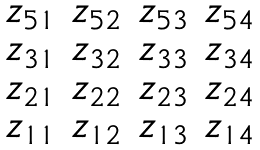<formula> <loc_0><loc_0><loc_500><loc_500>\begin{matrix} z _ { 5 1 } & z _ { 5 2 } & z _ { 5 3 } & z _ { 5 4 } \\ z _ { 3 1 } & z _ { 3 2 } & z _ { 3 3 } & z _ { 3 4 } \\ z _ { 2 1 } & z _ { 2 2 } & z _ { 2 3 } & z _ { 2 4 } \\ z _ { 1 1 } & z _ { 1 2 } & z _ { 1 3 } & z _ { 1 4 } \\ \end{matrix}</formula> 